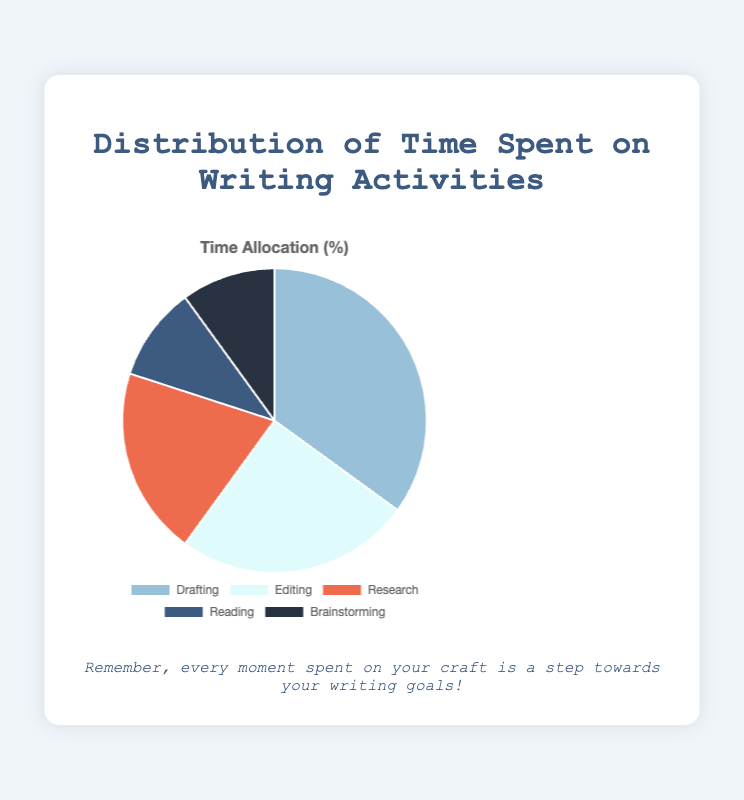What percentage of your time is spent on drafting? The pie chart shows that drafting takes up 35% of the total time spent on writing activities.
Answer: 35% Which activity takes up the second most amount of time? By looking at the pie chart, we can see that editing has the second-largest slice of the pie, indicating it takes up the second most amount of time after drafting.
Answer: Editing How does the time spent on reading compare to the time spent on brainstorming? The chart shows that the slices for reading and brainstorming are of equal size, indicating that the time spent on both activities is the same.
Answer: Equal Which activity requires more time, research or editing? By comparing the sizes of the slices for research and editing, we can see that the editing slice is larger, indicating that more time is spent on editing.
Answer: Editing What is the combined percentage of time spent on reading and brainstorming? Reading takes up 10% and brainstorming takes up 10%. Adding these together, 10% + 10% = 20%.
Answer: 20% What is the difference in the percentage of time spent on drafting and editing? Drafting takes up 35% of the time and editing takes up 25%. The difference is calculated as 35% - 25% = 10%.
Answer: 10% If you added 5% more time to research, how would its percentage compare to editing? Currently, research is at 20%. Adding 5% would make it 25%, which would then be equal to the time spent on editing.
Answer: Equal How much more time is spent on drafting compared to research? The percentage of time spent on drafting is 35%, and for research, it is 20%. The difference is 35% - 20% = 15%.
Answer: 15% Which color in the chart represents brainstorming? The chart shows that brainstorming is represented by the color dark blue.
Answer: Dark blue What percentage of time is allocated to non-drafting activities? The total time spent on all activities is 100%. Subtracting the time spent on drafting (35%), we get 100% - 35% = 65%.
Answer: 65% 